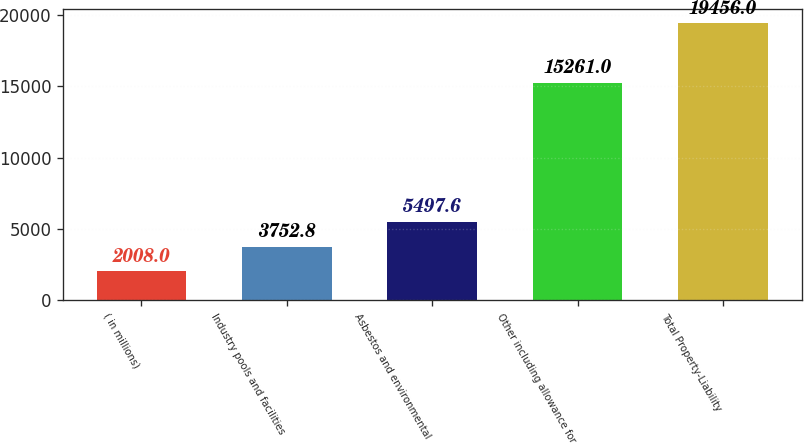<chart> <loc_0><loc_0><loc_500><loc_500><bar_chart><fcel>( in millions)<fcel>Industry pools and facilities<fcel>Asbestos and environmental<fcel>Other including allowance for<fcel>Total Property-Liability<nl><fcel>2008<fcel>3752.8<fcel>5497.6<fcel>15261<fcel>19456<nl></chart> 